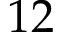<formula> <loc_0><loc_0><loc_500><loc_500>1 2</formula> 